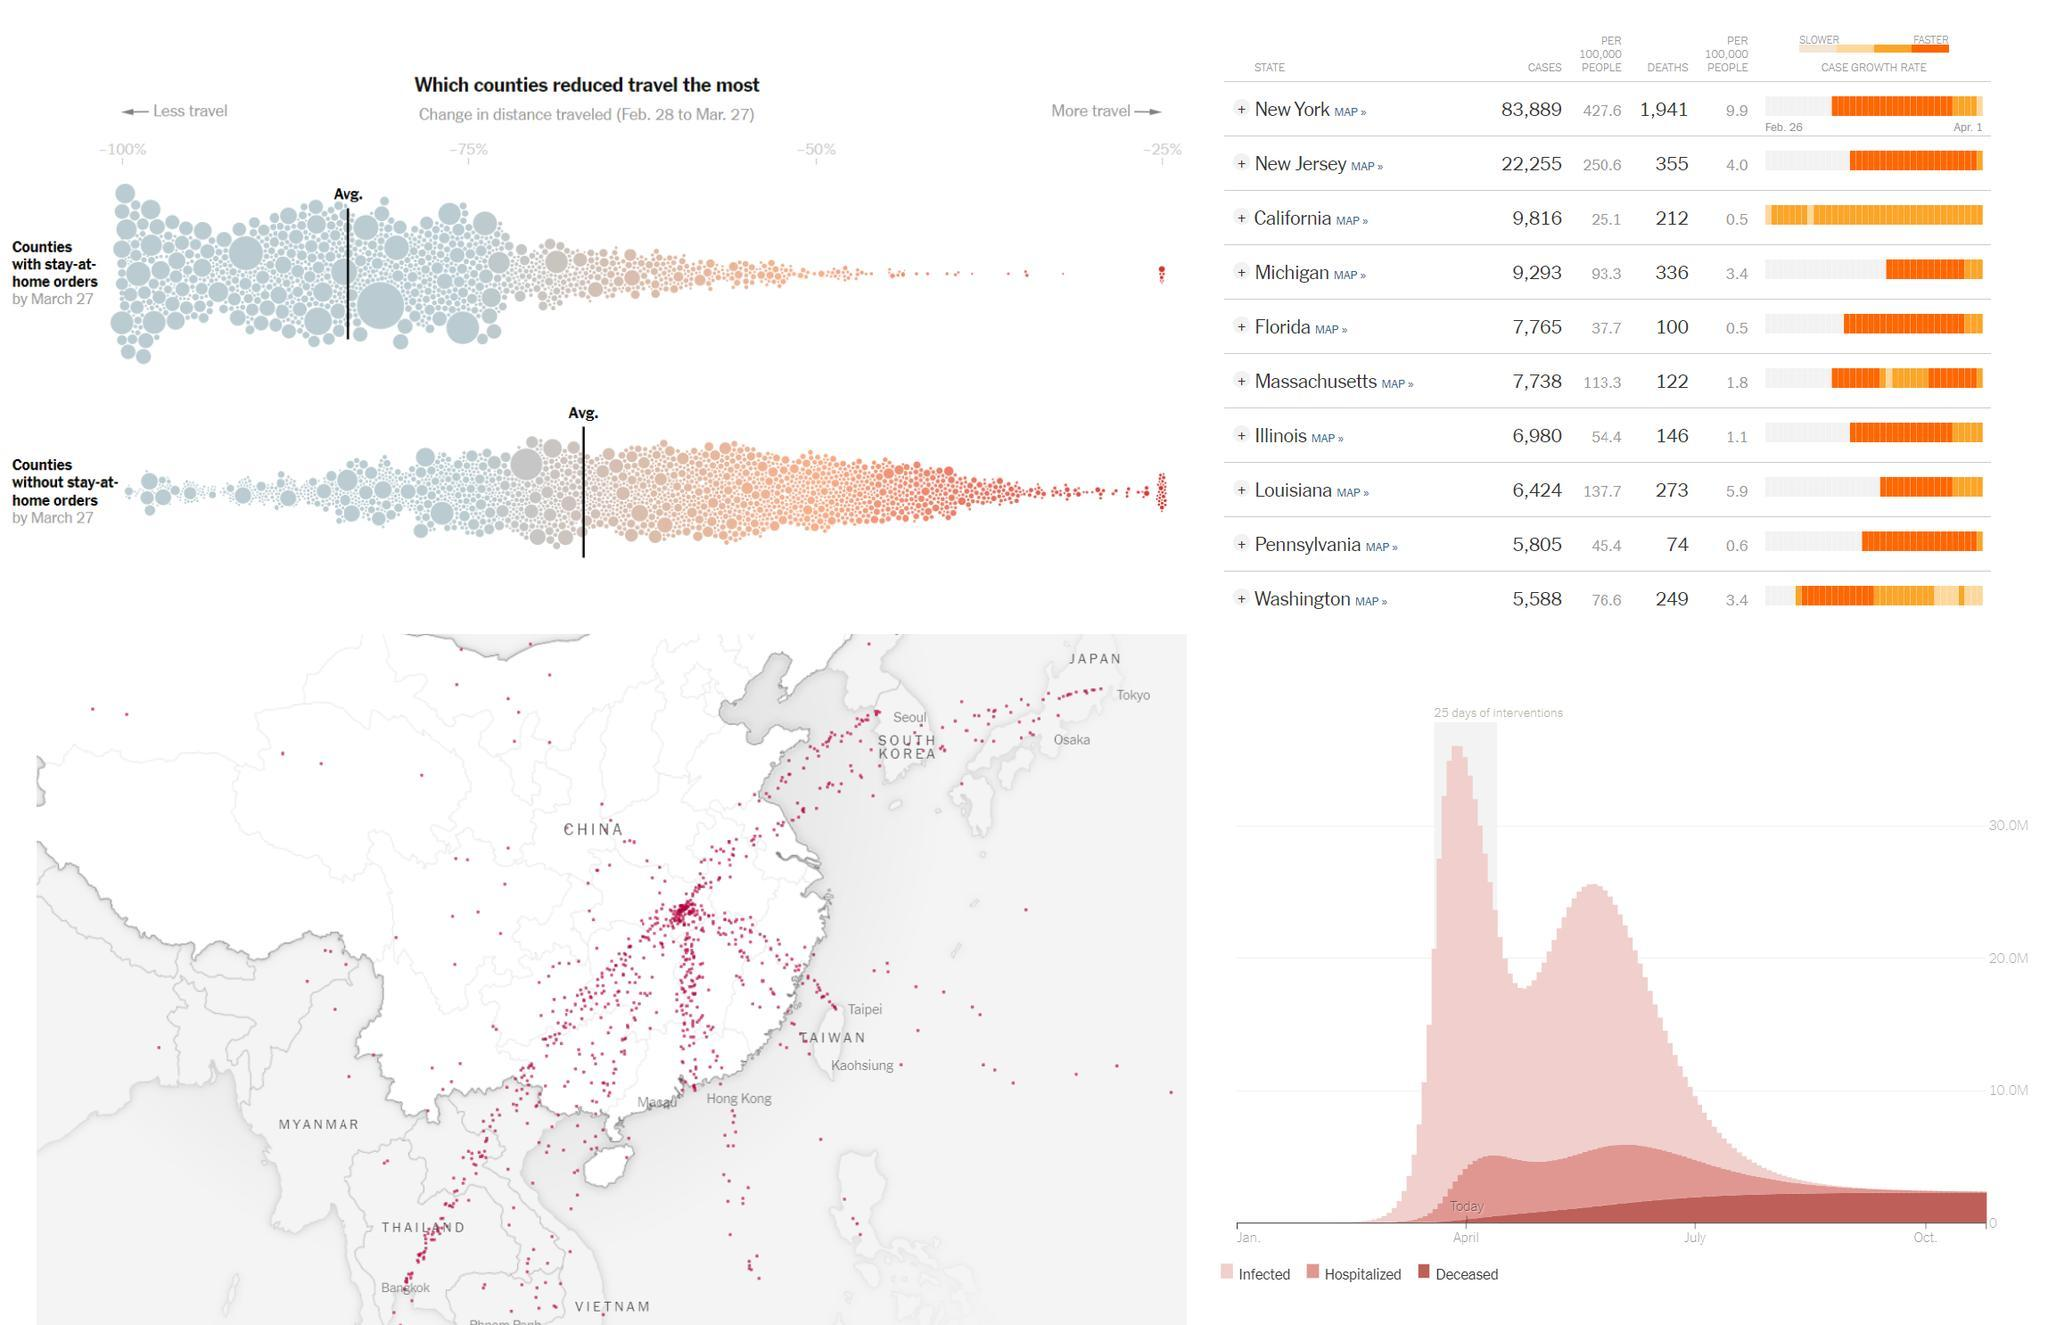Which state has Eighth highest number of cases from Feb 28 to Mar 27?
Answer the question with a short phrase. Louisiana Which state comes in first in number of deaths per 100,000 people? New York Which state comes in fifth in number of cases per 100,000 people? Michigan Which state comes in third in number of deaths per 100,000 people? New Jersey Which state comes in fourth in number of cases per 100,000 people? Massachusetts Which states has the least number of deaths per 100,000 people? Florida,California Which state has Third highest number of deaths from Feb 28 to Mar 27? Michigan Which state has second highest number of cases from Feb 28 to Mar 27? New Jersey Which states has the least number of cases per 100,000 people? California Which state comes in second in number of deaths per 100,000 people? Louisiana Which state has Fifth highest number of cases from Feb 28 to Mar 27? Florida Which state comes in third in number of cases per 100,000 people? Louisiana 